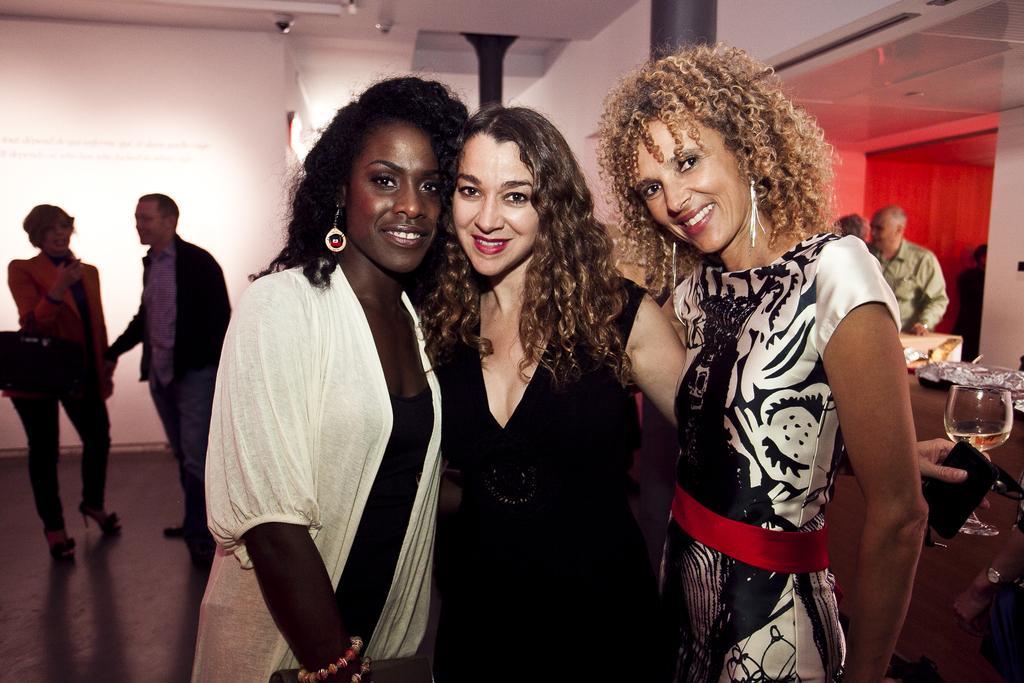Can you describe this image briefly? In this picture we can see group of people, in the middle of the image we can see three women, they are smiling and the middle woman is holding a mobile and a glass in her hand, in the background we can see few things on the table. 